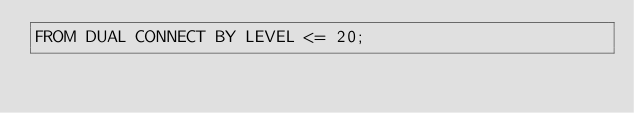Convert code to text. <code><loc_0><loc_0><loc_500><loc_500><_SQL_>FROM DUAL CONNECT BY LEVEL <= 20;</code> 